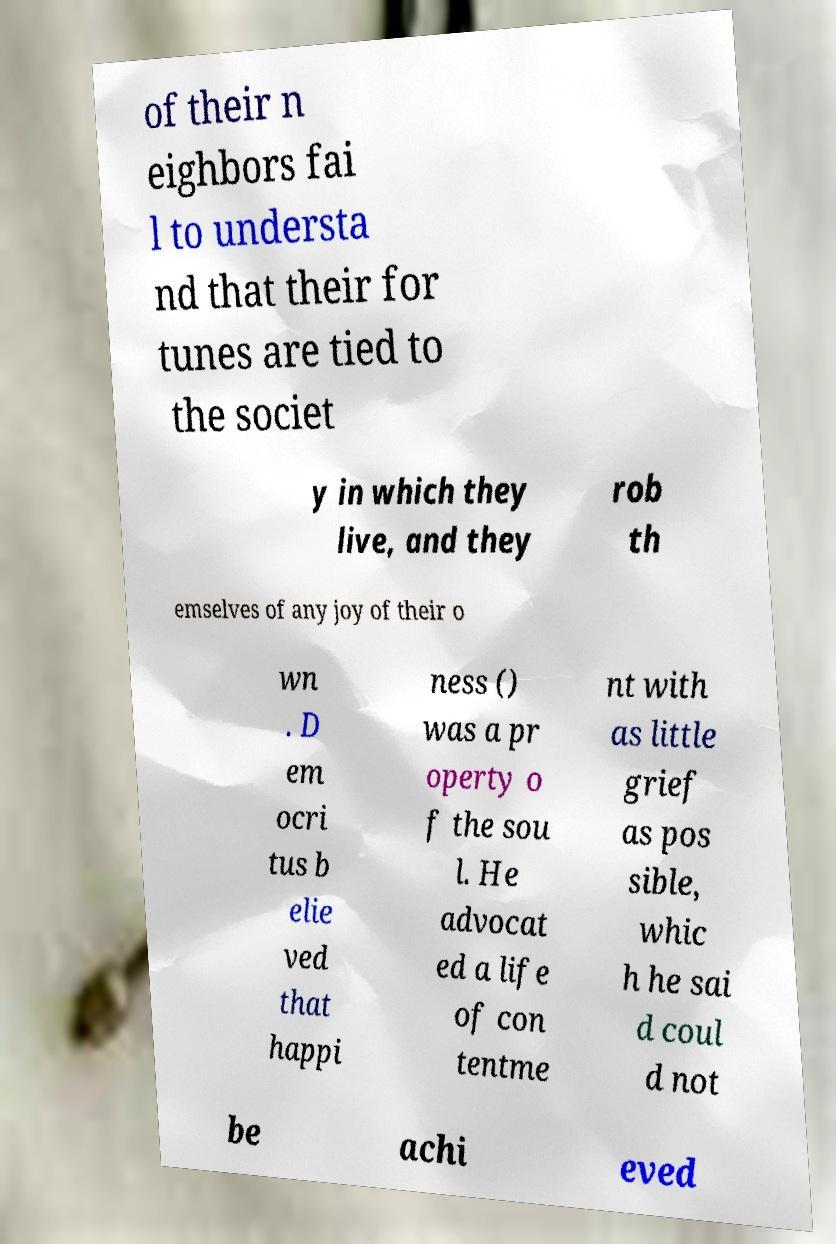Can you accurately transcribe the text from the provided image for me? of their n eighbors fai l to understa nd that their for tunes are tied to the societ y in which they live, and they rob th emselves of any joy of their o wn . D em ocri tus b elie ved that happi ness () was a pr operty o f the sou l. He advocat ed a life of con tentme nt with as little grief as pos sible, whic h he sai d coul d not be achi eved 